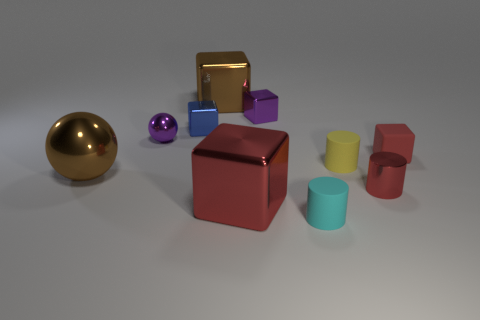Subtract all blue blocks. How many blocks are left? 4 Subtract all small matte cylinders. How many cylinders are left? 1 Subtract 0 cyan cubes. How many objects are left? 10 Subtract all cylinders. How many objects are left? 7 Subtract 3 cylinders. How many cylinders are left? 0 Subtract all yellow balls. Subtract all red cubes. How many balls are left? 2 Subtract all yellow cylinders. How many brown balls are left? 1 Subtract all big red metal things. Subtract all blocks. How many objects are left? 4 Add 5 large blocks. How many large blocks are left? 7 Add 5 small rubber blocks. How many small rubber blocks exist? 6 